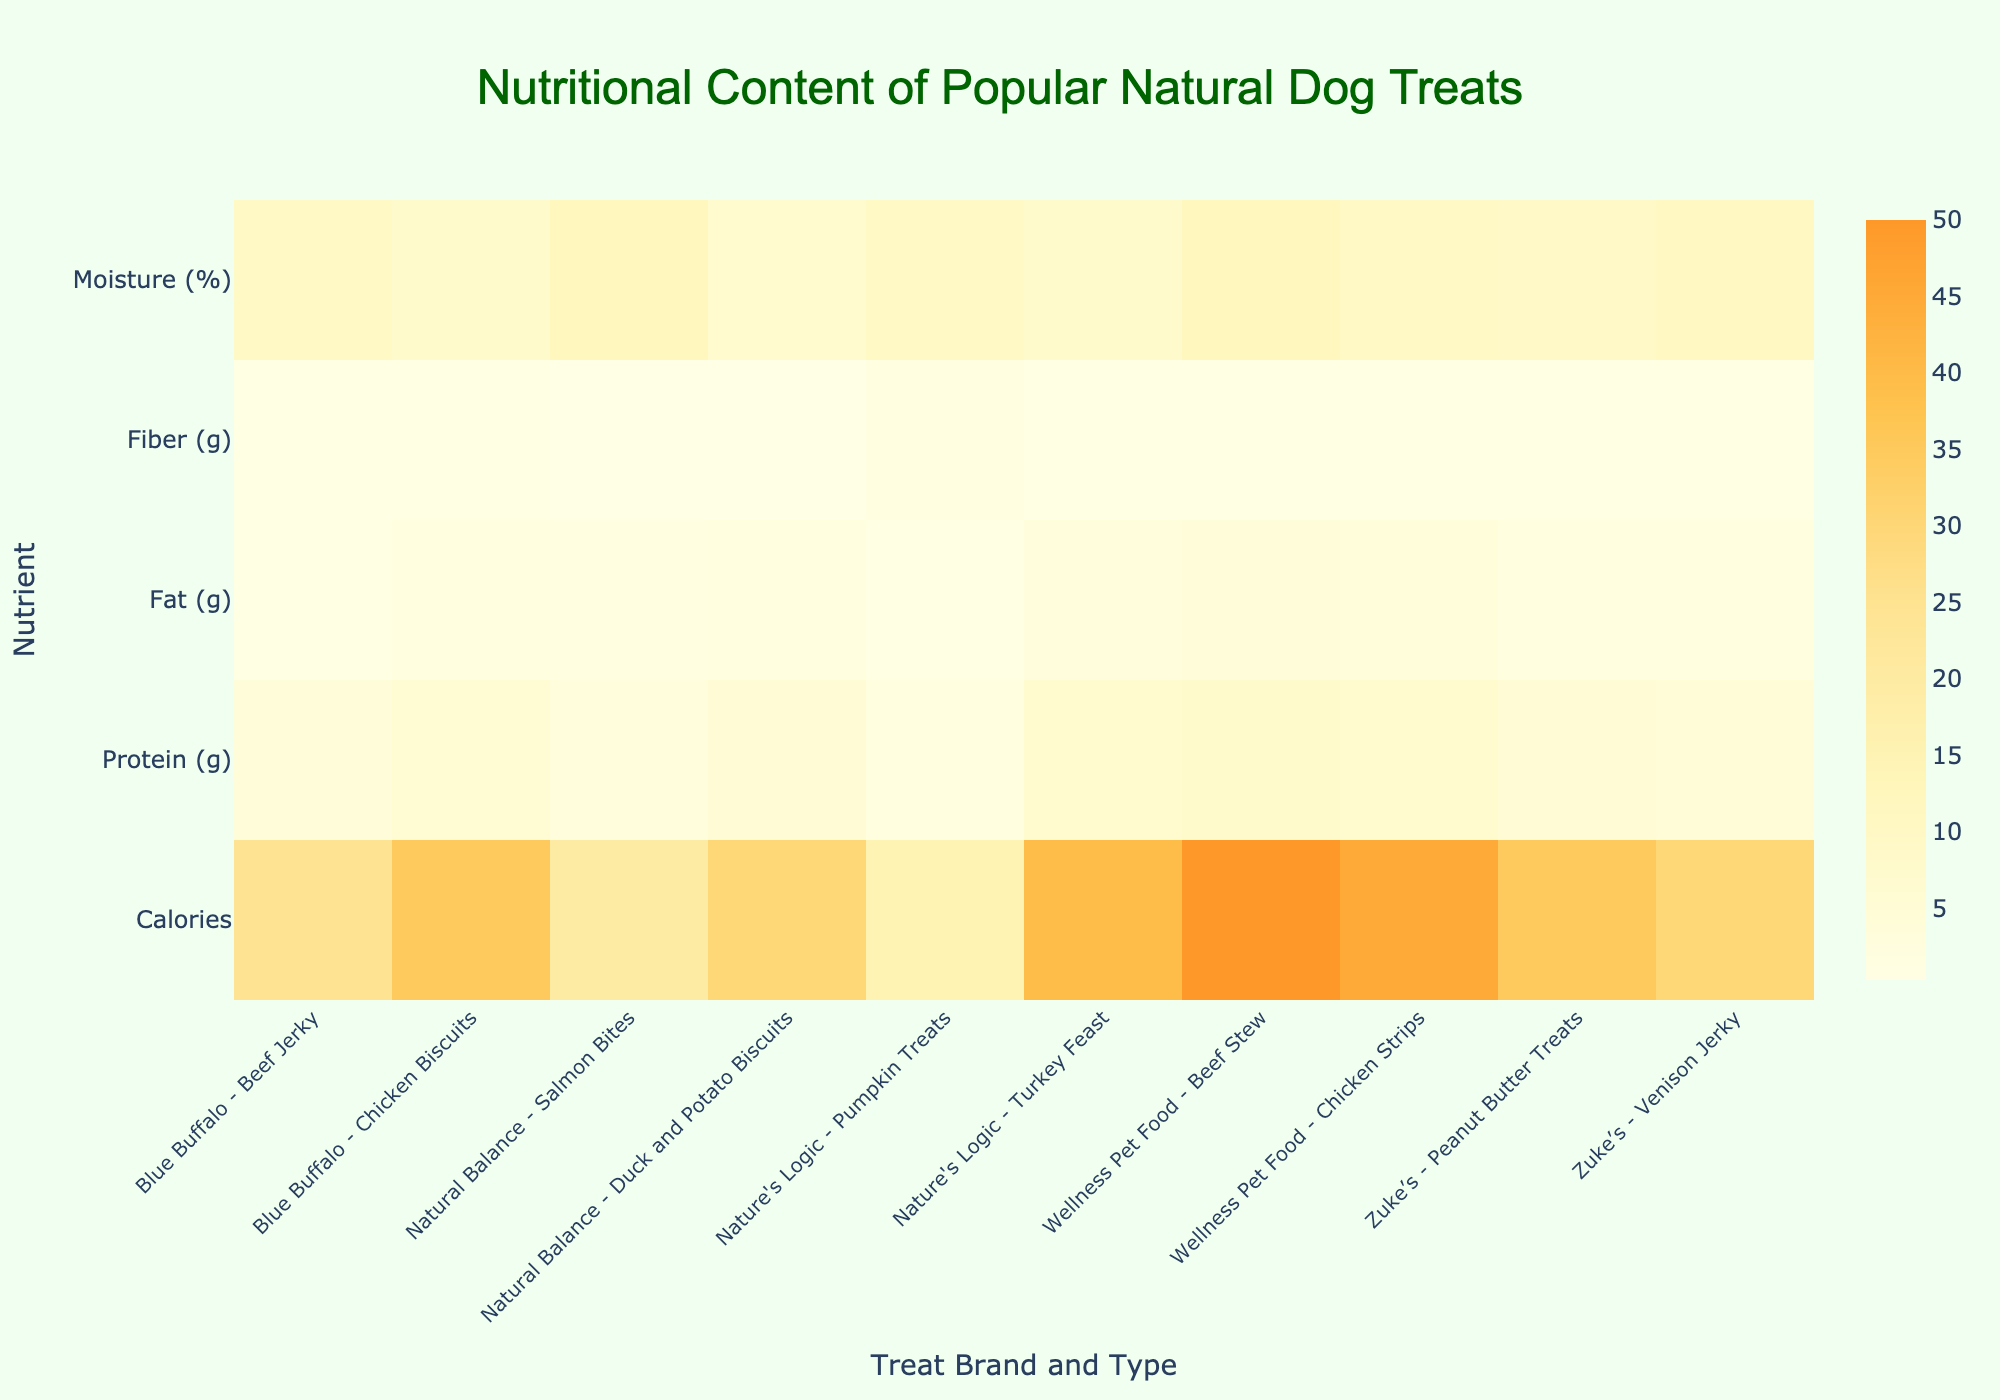What is the title of the figure? The title is usually placed at the top of the figure. In this case, it should be prominently displayed.
Answer: Nutritional Content of Popular Natural Dog Treats Which brand and type of dog treat has the highest calorie content? Scan through the heatmap and find the highest value under the "Calories" row. Look for the corresponding treat name on the x-axis.
Answer: Wellness Pet Food - Beef Stew Which nutrient has the lowest overall variation among the dog treats? To find the nutrient with the lowest variation, visually inspect the consistency of the color shades in each row. The row with the least color variation represents the lowest variation.
Answer: Fiber (g) How many dog treats have a moisture content of 10%? Look at the "Moisture (%)" row and count the number of cells with the value of 10 units on the heatmap.
Answer: 3 treats Which treat has the highest protein content and what brand is it? Find the highest value in the "Protein (g)" row and then note the associated treat on the x-axis.
Answer: Wellness Pet Food - Beef Stew Compare the fat content between Blue Buffalo - Chicken Biscuits and Zuke’s - Venison Jerky. Which has more fat content? Check the values in the "Fat (g)" row for both treats and compare them.
Answer: Blue Buffalo - Chicken Biscuits What is the average fiber content across all listed dog treats? Sum all the values in the "Fiber (g)" row and divide by the number of treats.
Answer: 0.8 Which brand has the most variety of treat types listed on the heatmap? Count the number of entries for each brand and find the one with the highest count.
Answer: Wellness Pet Food Which two treats have the closest calorie content? Compare the calorie values in the "Calories" row and identify the two closest values.
Answer: Natural Balance - Duck and Potato Biscuits and Zuke’s - Venison Jerky What is the difference in moisture content between Nature’s Logic - Turkey Feast and Blue Buffalo - Chicken Biscuits? Subtract the moisture content of Blue Buffalo - Chicken Biscuits from Nature’s Logic - Turkey Feast.
Answer: 2 